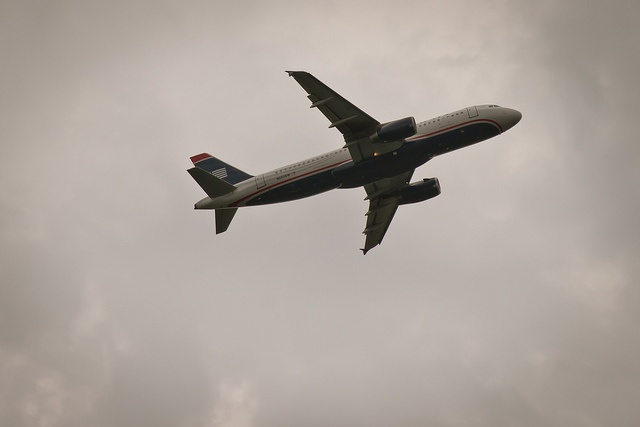Describe the objects in this image and their specific colors. I can see a airplane in gray, black, darkgray, and maroon tones in this image. 